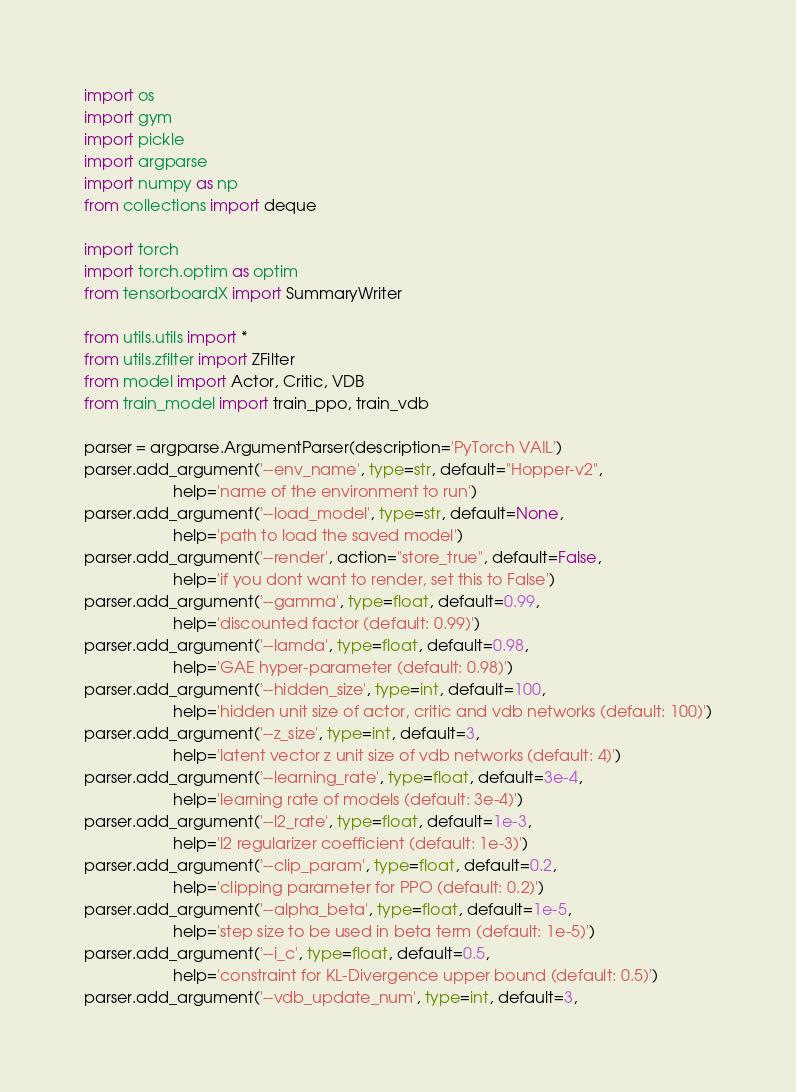Convert code to text. <code><loc_0><loc_0><loc_500><loc_500><_Python_>import os
import gym
import pickle
import argparse
import numpy as np
from collections import deque

import torch
import torch.optim as optim
from tensorboardX import SummaryWriter 

from utils.utils import *
from utils.zfilter import ZFilter
from model import Actor, Critic, VDB
from train_model import train_ppo, train_vdb

parser = argparse.ArgumentParser(description='PyTorch VAIL')
parser.add_argument('--env_name', type=str, default="Hopper-v2", 
                    help='name of the environment to run')
parser.add_argument('--load_model', type=str, default=None, 
                    help='path to load the saved model')
parser.add_argument('--render', action="store_true", default=False, 
                    help='if you dont want to render, set this to False')
parser.add_argument('--gamma', type=float, default=0.99, 
                    help='discounted factor (default: 0.99)')
parser.add_argument('--lamda', type=float, default=0.98, 
                    help='GAE hyper-parameter (default: 0.98)')
parser.add_argument('--hidden_size', type=int, default=100, 
                    help='hidden unit size of actor, critic and vdb networks (default: 100)')
parser.add_argument('--z_size', type=int, default=3, 
                    help='latent vector z unit size of vdb networks (default: 4)')
parser.add_argument('--learning_rate', type=float, default=3e-4, 
                    help='learning rate of models (default: 3e-4)')
parser.add_argument('--l2_rate', type=float, default=1e-3, 
                    help='l2 regularizer coefficient (default: 1e-3)')
parser.add_argument('--clip_param', type=float, default=0.2, 
                    help='clipping parameter for PPO (default: 0.2)')
parser.add_argument('--alpha_beta', type=float, default=1e-5, 
                    help='step size to be used in beta term (default: 1e-5)')
parser.add_argument('--i_c', type=float, default=0.5, 
                    help='constraint for KL-Divergence upper bound (default: 0.5)')
parser.add_argument('--vdb_update_num', type=int, default=3, </code> 